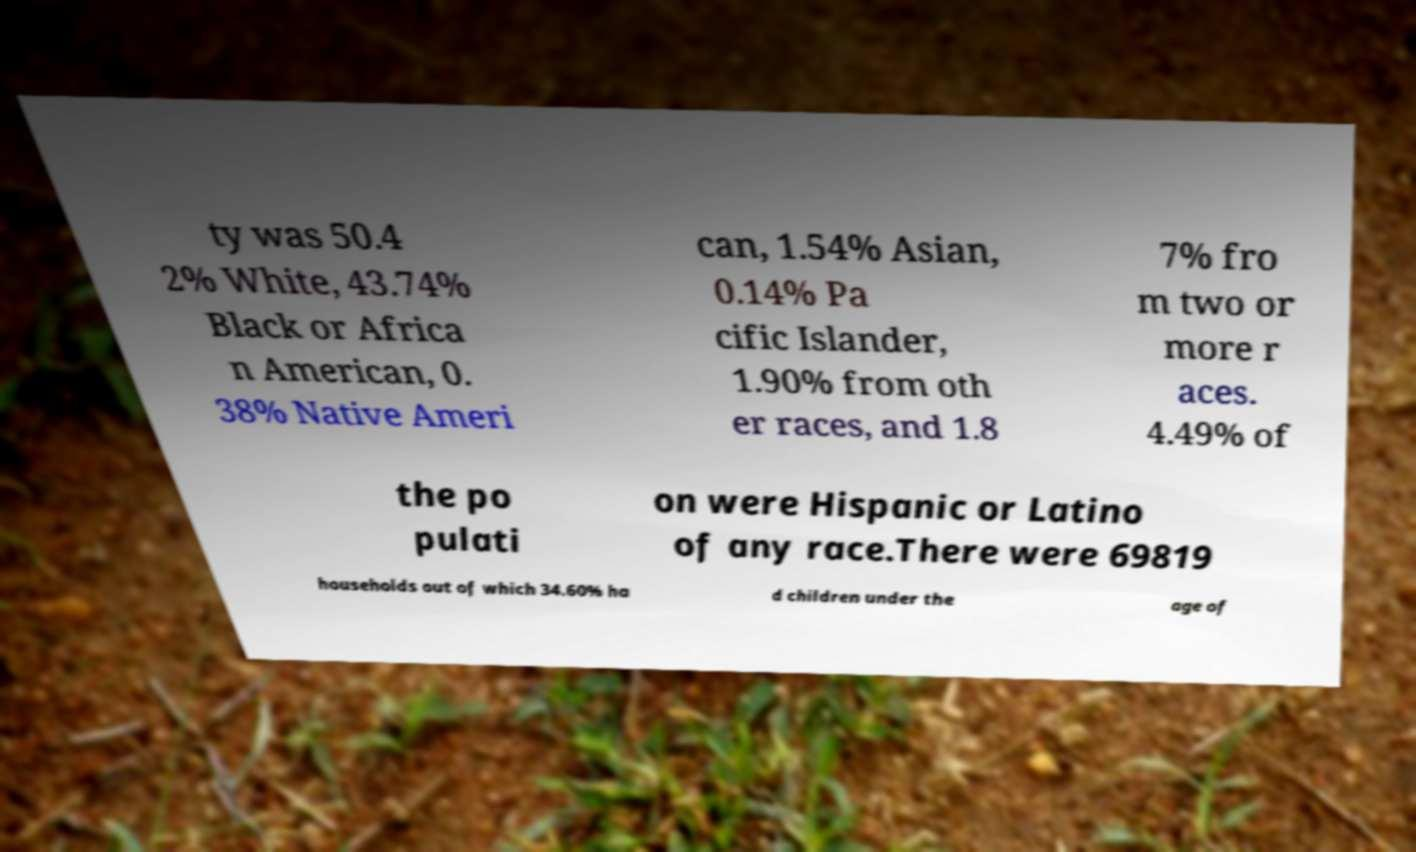Please read and relay the text visible in this image. What does it say? ty was 50.4 2% White, 43.74% Black or Africa n American, 0. 38% Native Ameri can, 1.54% Asian, 0.14% Pa cific Islander, 1.90% from oth er races, and 1.8 7% fro m two or more r aces. 4.49% of the po pulati on were Hispanic or Latino of any race.There were 69819 households out of which 34.60% ha d children under the age of 